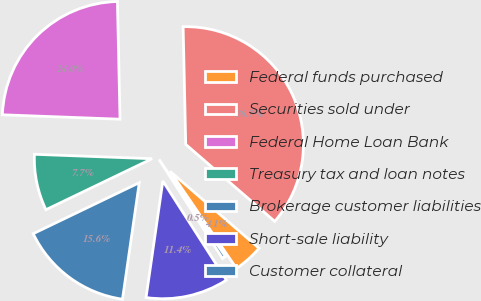Convert chart to OTSL. <chart><loc_0><loc_0><loc_500><loc_500><pie_chart><fcel>Federal funds purchased<fcel>Securities sold under<fcel>Federal Home Loan Bank<fcel>Treasury tax and loan notes<fcel>Brokerage customer liabilities<fcel>Short-sale liability<fcel>Customer collateral<nl><fcel>4.1%<fcel>36.7%<fcel>24.05%<fcel>7.73%<fcel>15.59%<fcel>11.35%<fcel>0.48%<nl></chart> 